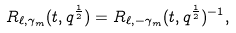<formula> <loc_0><loc_0><loc_500><loc_500>R _ { \ell , \gamma _ { m } } ( t , q ^ { \frac { 1 } { 2 } } ) = R _ { \ell , - \gamma _ { m } } ( t , q ^ { \frac { 1 } { 2 } } ) ^ { - 1 } ,</formula> 